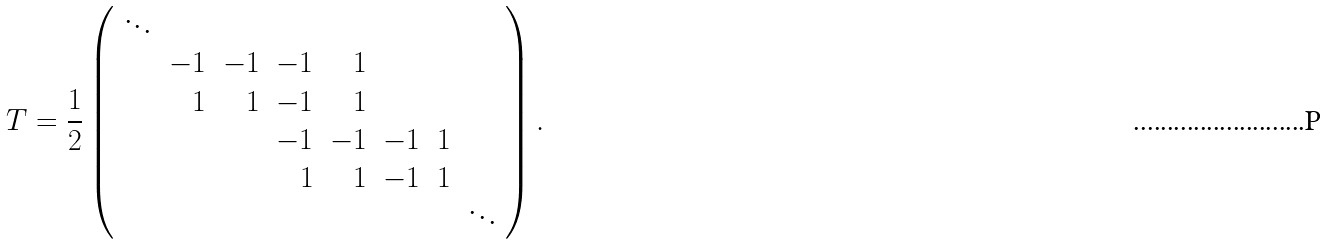Convert formula to latex. <formula><loc_0><loc_0><loc_500><loc_500>T = \frac { 1 } { 2 } \left ( \begin{array} { r r r r r r r r } \ddots & & & & & & & \\ & - 1 & - 1 & - 1 & 1 & & & \\ & 1 & 1 & - 1 & 1 & & & \\ & & & - 1 & - 1 & - 1 & 1 & \\ & & & 1 & 1 & - 1 & 1 & \\ & & & & & & & \ddots \end{array} \right ) .</formula> 